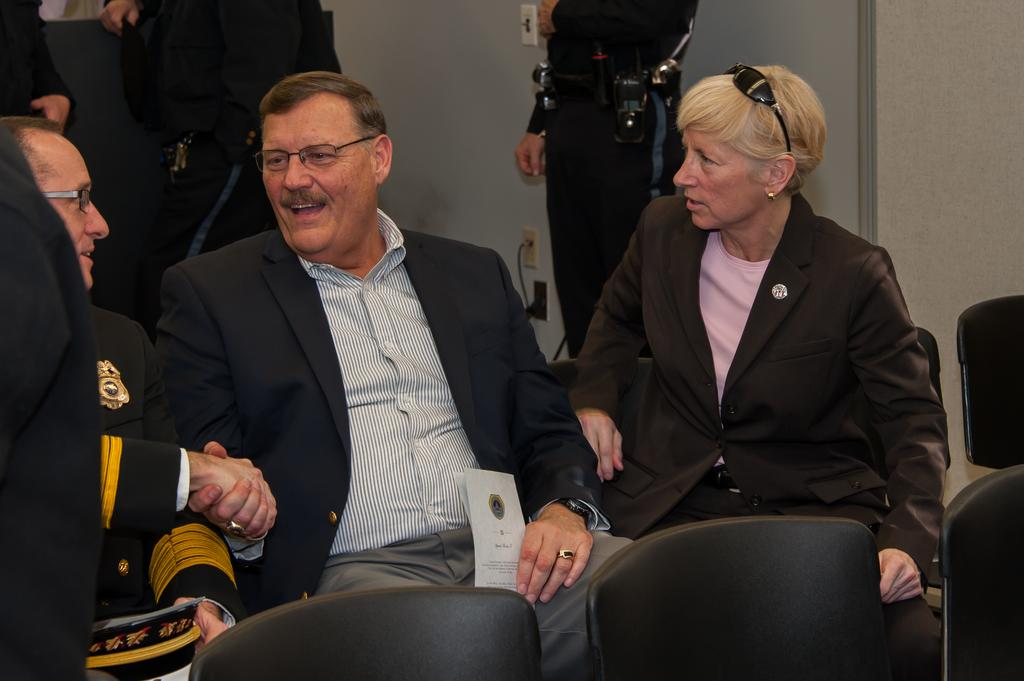How many people are sitting on chairs in the image? There are three people sitting on chairs in the image. What are the two men doing in the image? The two men are shaking hands and smiling. Are there any empty chairs in the image? Yes, there are empty chairs in the image. What else can be seen in the image besides the people sitting and standing? There is a wall visible in the image. What type of health advice can be seen on the wall in the image? There is no health advice visible on the wall in the image. Can you see any bears in the image? No, there are no bears present in the image. 